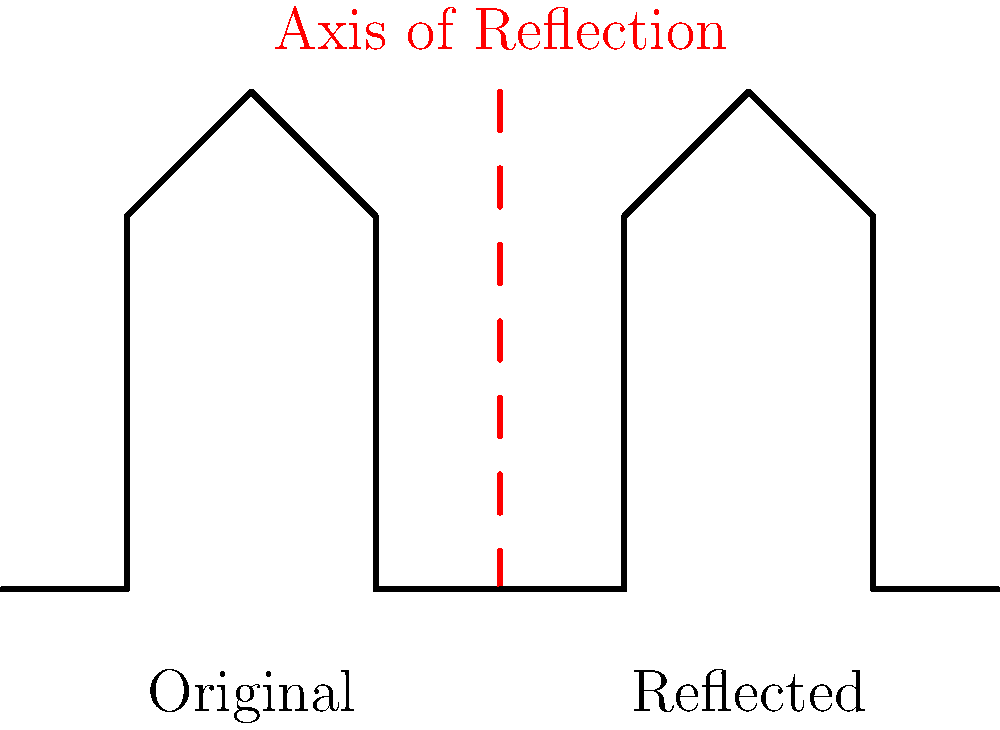Consider the symmetrical architectural facade shown in the image. If this facade is reflected across the vertical axis indicated by the red dashed line, what transformation would correctly describe the relationship between the original facade and its reflection? To determine the correct transformation, let's analyze the properties of the reflection:

1. The original facade and its reflection are mirror images of each other.
2. The axis of reflection (red dashed line) acts as a mirror line.
3. Every point on the original facade has a corresponding point on the reflected facade.
4. The distance from any point on the original facade to the axis of reflection is equal to the distance from its corresponding point on the reflected facade to the axis.
5. The line connecting any point on the original facade to its corresponding point on the reflected facade is perpendicular to the axis of reflection.

These properties are consistent with an isometric transformation known as a reflection. Specifically, this is a reflection across a vertical line (the axis of reflection).

In transformational geometry, a reflection across a vertical line can be described mathematically as:

$$(x, y) \rightarrow (-x, y)$$

where the vertical line of reflection is the y-axis (x = 0).

In this case, the axis of reflection is not at x = 0, but the principle remains the same. The x-coordinates of all points are transformed relative to the axis of reflection, while the y-coordinates remain unchanged.

This transformation preserves the size and shape of the original figure, only changing its orientation. It is an example of an isometry, which preserves distances between points.
Answer: Reflection across a vertical axis 